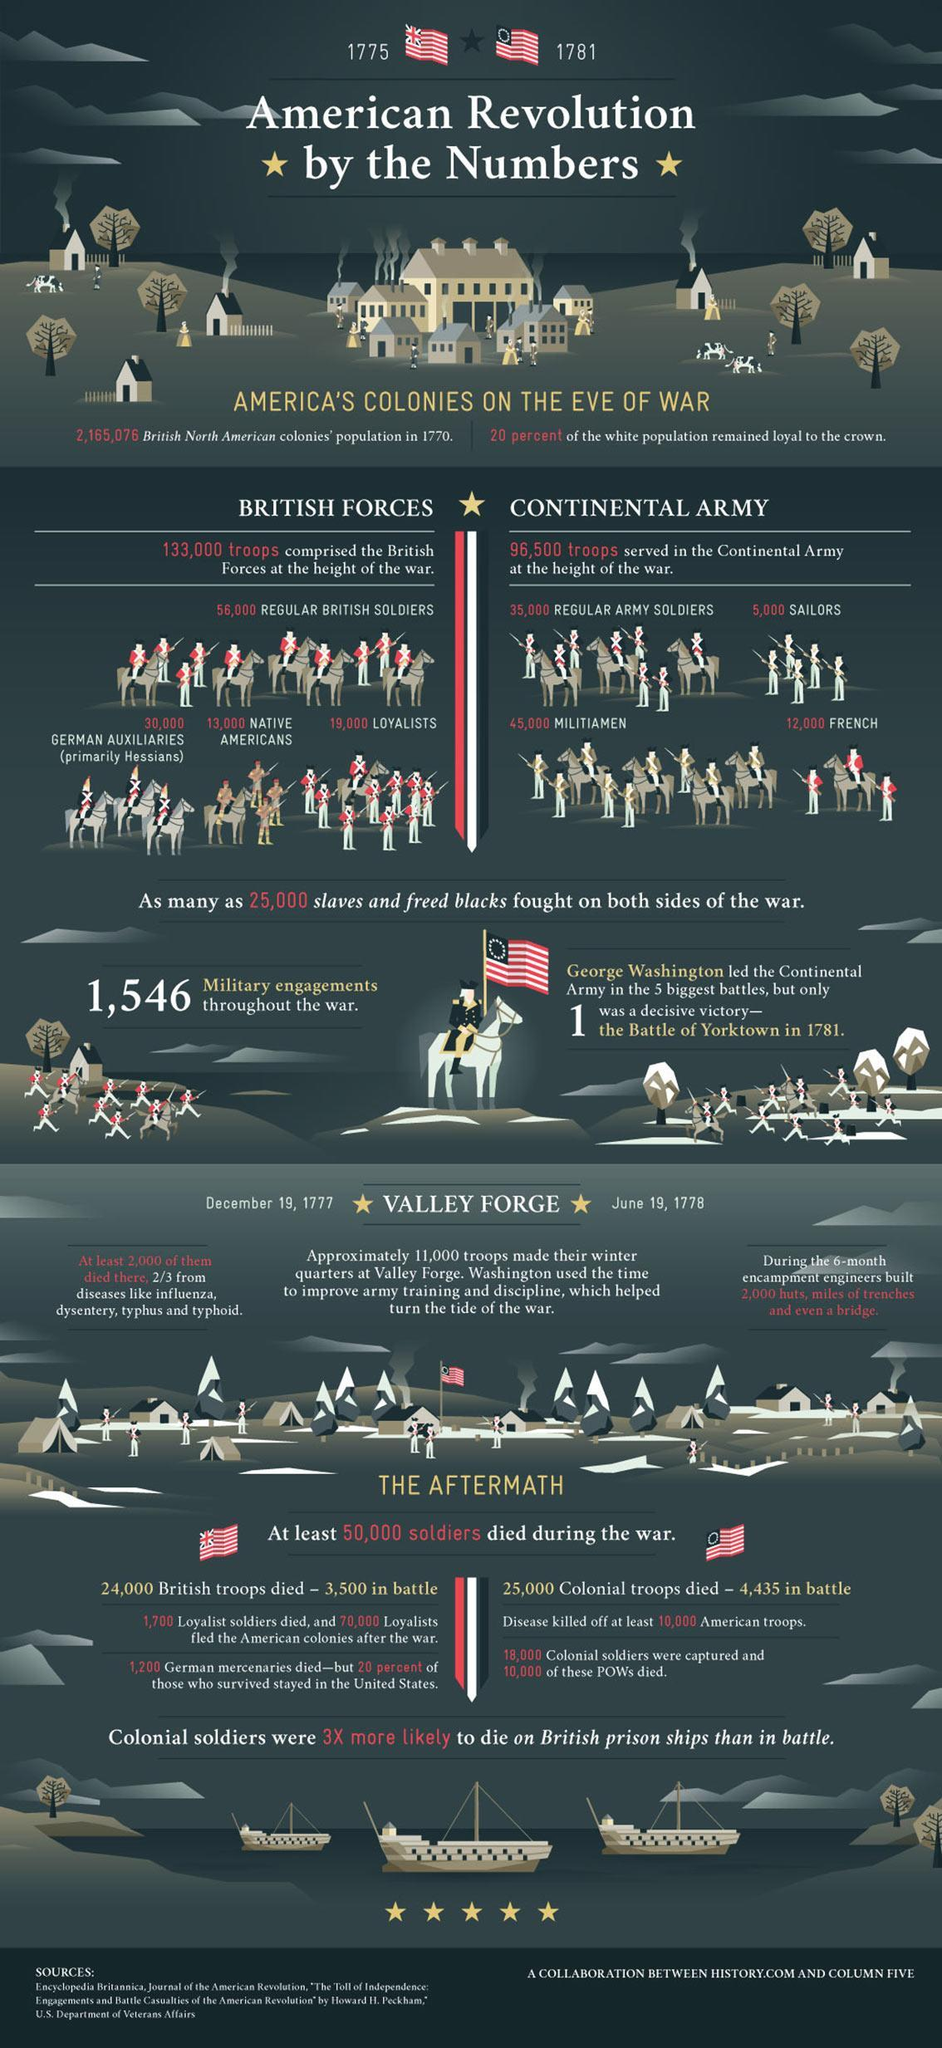How many troops of militiamen and French soldiers comprised Continental Army?
Answer the question with a short phrase. 57,000 How many sources are listed at the bottom? 3 Which groups were part of the British Forces in addition to regular British soldiers? GERMAN AUXILIARIES, NATIVE AMERICANS, LOYALISTS 